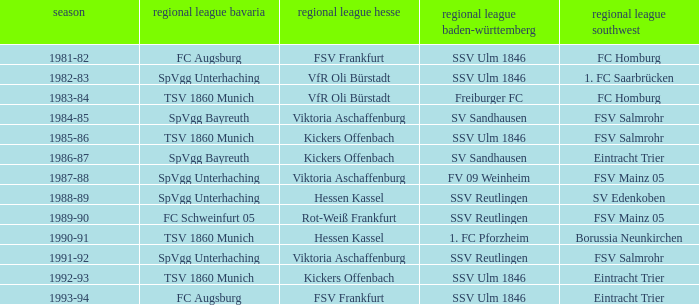Can you parse all the data within this table? {'header': ['season', 'regional league bavaria', 'regional league hesse', 'regional league baden-württemberg', 'regional league southwest'], 'rows': [['1981-82', 'FC Augsburg', 'FSV Frankfurt', 'SSV Ulm 1846', 'FC Homburg'], ['1982-83', 'SpVgg Unterhaching', 'VfR Oli Bürstadt', 'SSV Ulm 1846', '1. FC Saarbrücken'], ['1983-84', 'TSV 1860 Munich', 'VfR Oli Bürstadt', 'Freiburger FC', 'FC Homburg'], ['1984-85', 'SpVgg Bayreuth', 'Viktoria Aschaffenburg', 'SV Sandhausen', 'FSV Salmrohr'], ['1985-86', 'TSV 1860 Munich', 'Kickers Offenbach', 'SSV Ulm 1846', 'FSV Salmrohr'], ['1986-87', 'SpVgg Bayreuth', 'Kickers Offenbach', 'SV Sandhausen', 'Eintracht Trier'], ['1987-88', 'SpVgg Unterhaching', 'Viktoria Aschaffenburg', 'FV 09 Weinheim', 'FSV Mainz 05'], ['1988-89', 'SpVgg Unterhaching', 'Hessen Kassel', 'SSV Reutlingen', 'SV Edenkoben'], ['1989-90', 'FC Schweinfurt 05', 'Rot-Weiß Frankfurt', 'SSV Reutlingen', 'FSV Mainz 05'], ['1990-91', 'TSV 1860 Munich', 'Hessen Kassel', '1. FC Pforzheim', 'Borussia Neunkirchen'], ['1991-92', 'SpVgg Unterhaching', 'Viktoria Aschaffenburg', 'SSV Reutlingen', 'FSV Salmrohr'], ['1992-93', 'TSV 1860 Munich', 'Kickers Offenbach', 'SSV Ulm 1846', 'Eintracht Trier'], ['1993-94', 'FC Augsburg', 'FSV Frankfurt', 'SSV Ulm 1846', 'Eintracht Trier']]} Which oberliga südwes has an oberliga baden-württemberg of sv sandhausen in 1984-85? FSV Salmrohr. 